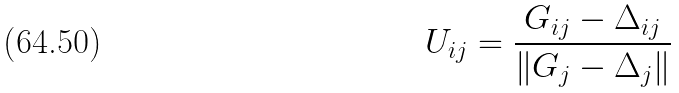<formula> <loc_0><loc_0><loc_500><loc_500>U _ { i j } = \frac { G _ { i j } - \Delta _ { i j } } { \| G _ { j } - \Delta _ { j } \| }</formula> 